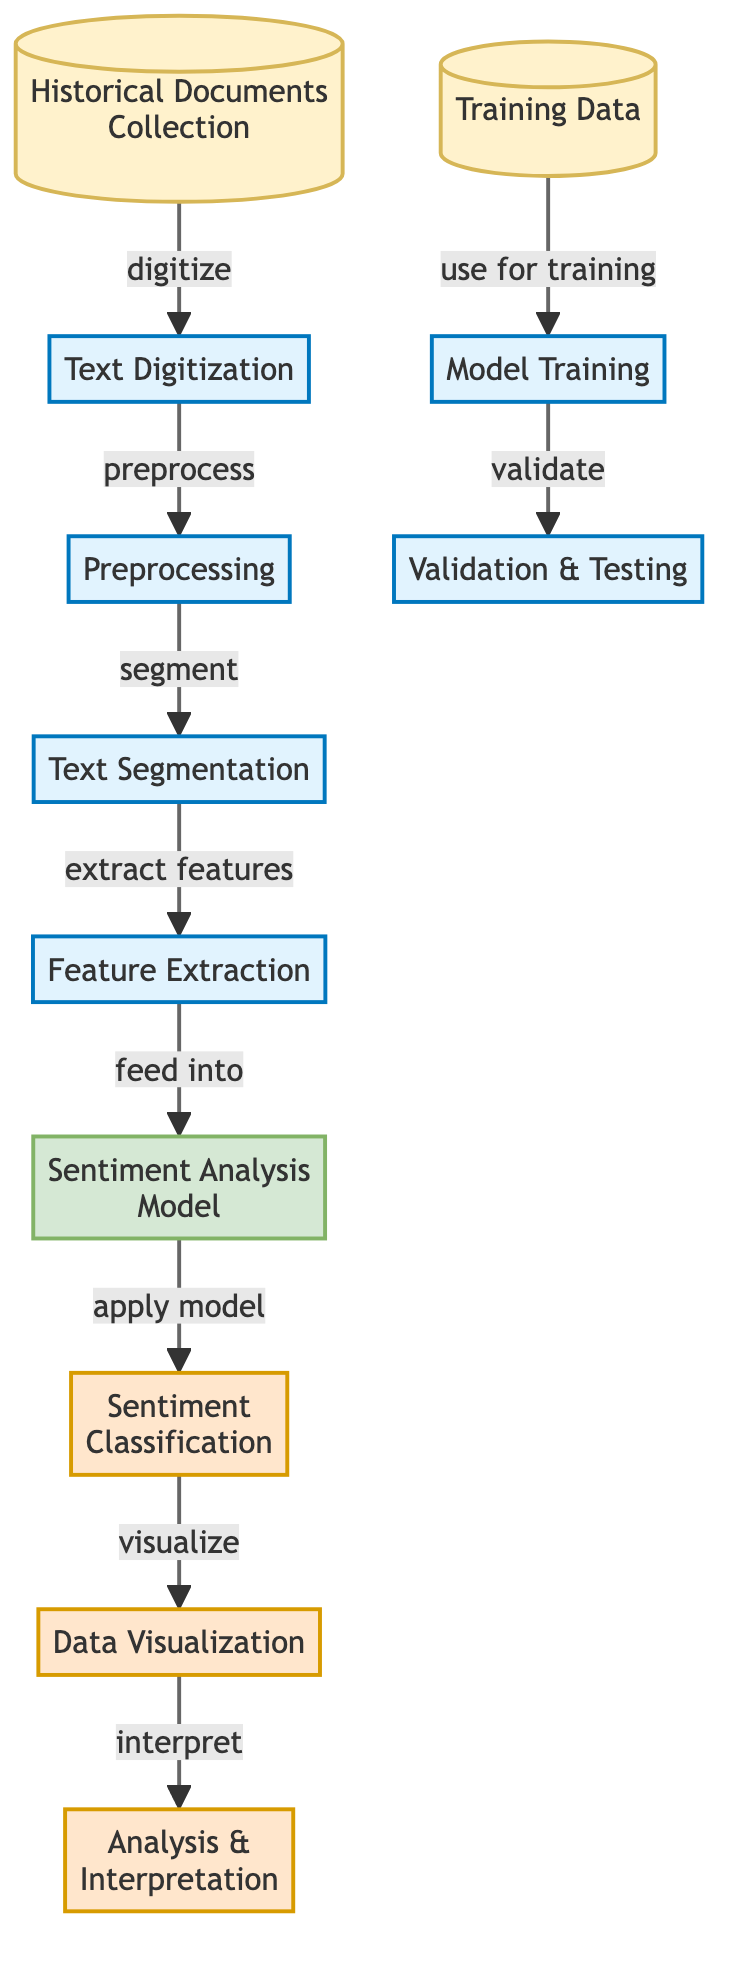What is the first step in the process? The first step in the process is "Historical Documents Collection". This is clearly shown as the starting node in the diagram before any processes begin.
Answer: Historical Documents Collection How many processes are in the diagram? The diagram has a total of six process nodes: Text Digitization, Preprocessing, Text Segmentation, Feature Extraction, Model Training, and Validation & Testing. Counting these nodes gives a total of six.
Answer: Six What type of data is used for Model Training? The data used for Model Training is referred to as "Training Data". This is indicated as the input specifically for the Model Training process in the diagram.
Answer: Training Data What follows after applying the Sentiment Analysis Model? After applying the Sentiment Analysis Model, the next step is "Sentiment Classification". This shows the flow from the model to its application for classification.
Answer: Sentiment Classification How are features extracted in the diagram? Features are extracted in the diagram through a process labeled "Feature Extraction" that directly follows "Text Segmentation". This indicates the sequential relationship of feature extraction following segmentation.
Answer: Feature Extraction How does the output of the model get interpreted? The output of the model is interpreted through an "Analysis & Interpretation" step, which comes after "Data Visualization" in the diagram. This indicates that visualization precedes interpretation.
Answer: Analysis & Interpretation What links "Feature Extraction" and "Sentiment Analysis Model"? "Feature Extraction" feeds into the "Sentiment Analysis Model". This is a direct connection indicated in the flow of the diagram.
Answer: Feed into What is shown as the final output of this diagram? The final output of the diagram is represented by "Analysis & Interpretation". This is the last step in the flow after visualization of the data.
Answer: Analysis & Interpretation 